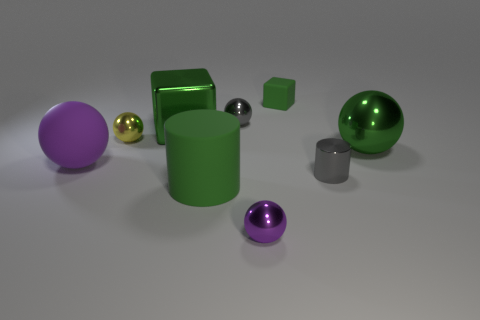Is there any indication of movement or stillness in the image? The image portrays a sense of stillness with no indication of movement. The objects are statically placed, with no signs of motion blurs or disturbances, suggesting a deliberately arranged composition perhaps used for a still life study. 